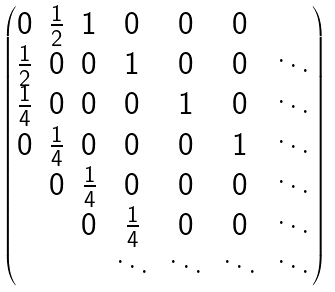Convert formula to latex. <formula><loc_0><loc_0><loc_500><loc_500>\begin{pmatrix} 0 & \frac { 1 } { 2 } & 1 & 0 & 0 & 0 \\ \frac { 1 } { 2 } & 0 & 0 & 1 & 0 & 0 & \ddots \\ \frac { 1 } { 4 } & 0 & 0 & 0 & 1 & 0 & \ddots \\ 0 & \frac { 1 } { 4 } & 0 & 0 & 0 & 1 & \ddots \\ & 0 & \frac { 1 } { 4 } & 0 & 0 & 0 & \ddots \\ & & 0 & \frac { 1 } { 4 } & 0 & 0 & \ddots \\ & & & \ddots & \ddots & \ddots & \ddots \end{pmatrix}</formula> 